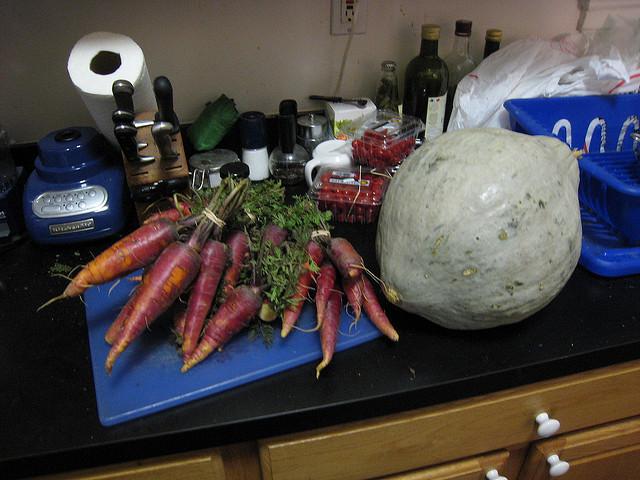How many handles are in the picture?
Keep it brief. 3. Is there a toilet roll on the desk?
Short answer required. No. Is there a block with knives on the counter?
Short answer required. Yes. 